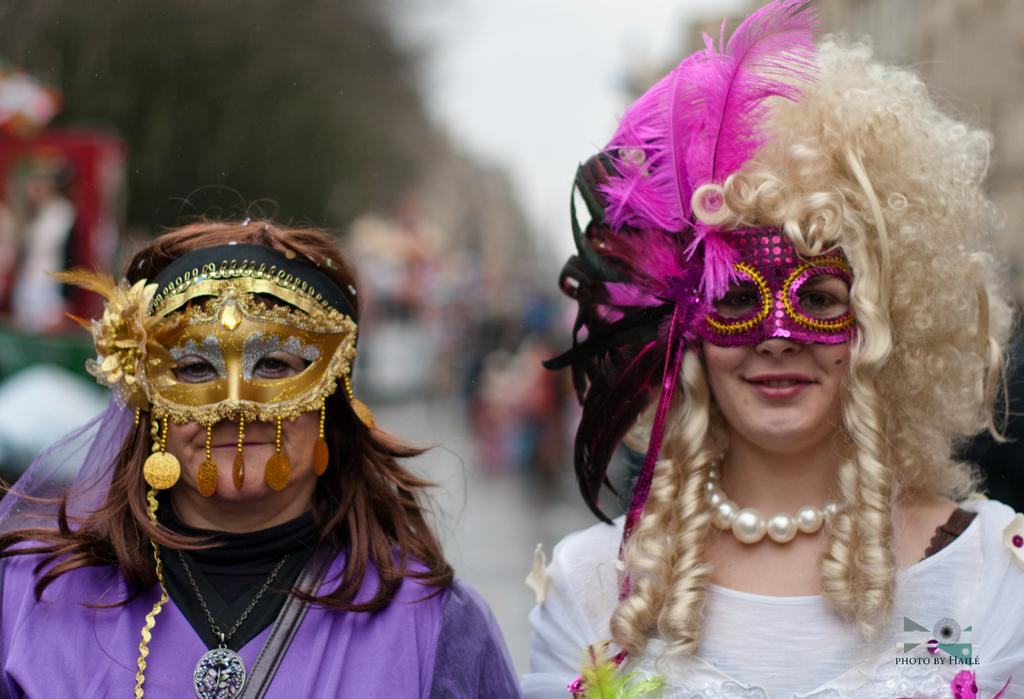How many people are in the image? There are two persons in the image. What are the persons wearing? The persons are wearing costumes. What can be seen on their faces? The persons have masks on their faces. What might the persons be doing in the image? The persons are posing for a photo. Can you describe the background of the image? The background of the image is blurred. What type of waves can be seen in the background of the image? There are no waves visible in the background of the image; the background is blurred. What hobbies do the persons in the image share? We cannot determine the hobbies of the persons in the image based on the provided facts. 